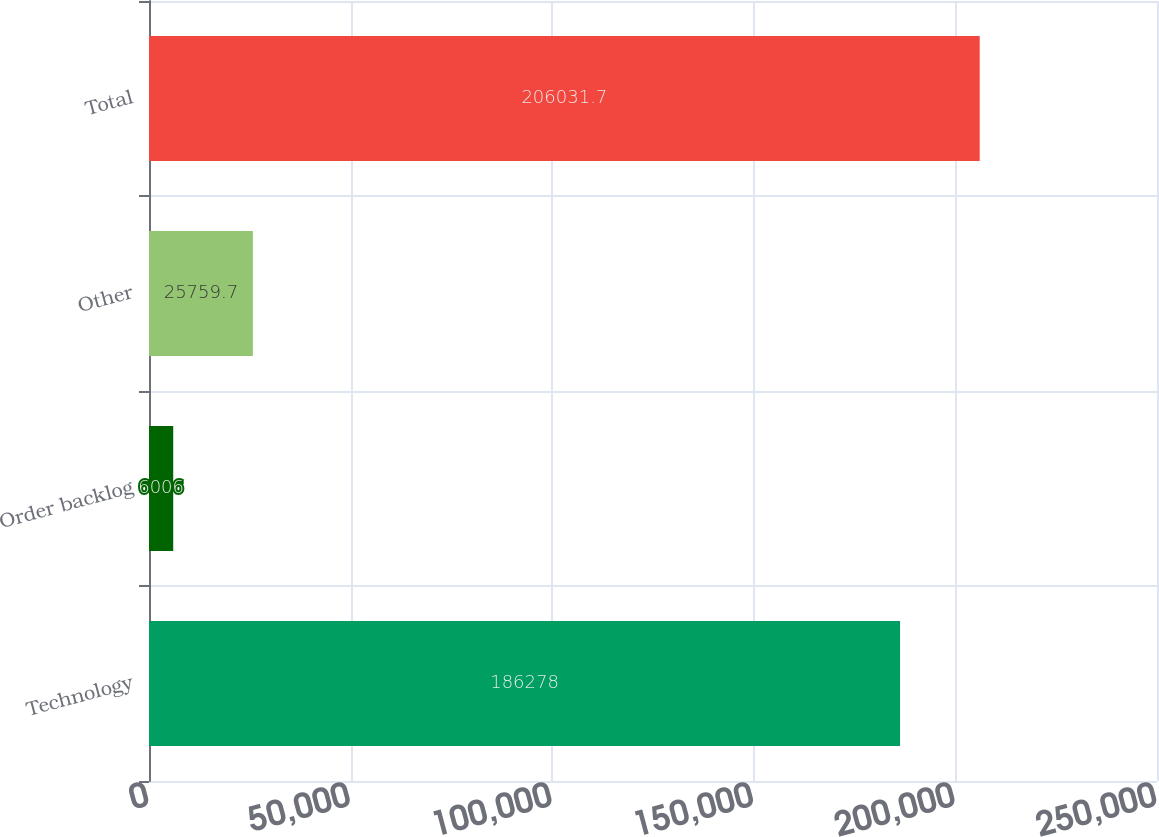Convert chart to OTSL. <chart><loc_0><loc_0><loc_500><loc_500><bar_chart><fcel>Technology<fcel>Order backlog<fcel>Other<fcel>Total<nl><fcel>186278<fcel>6006<fcel>25759.7<fcel>206032<nl></chart> 